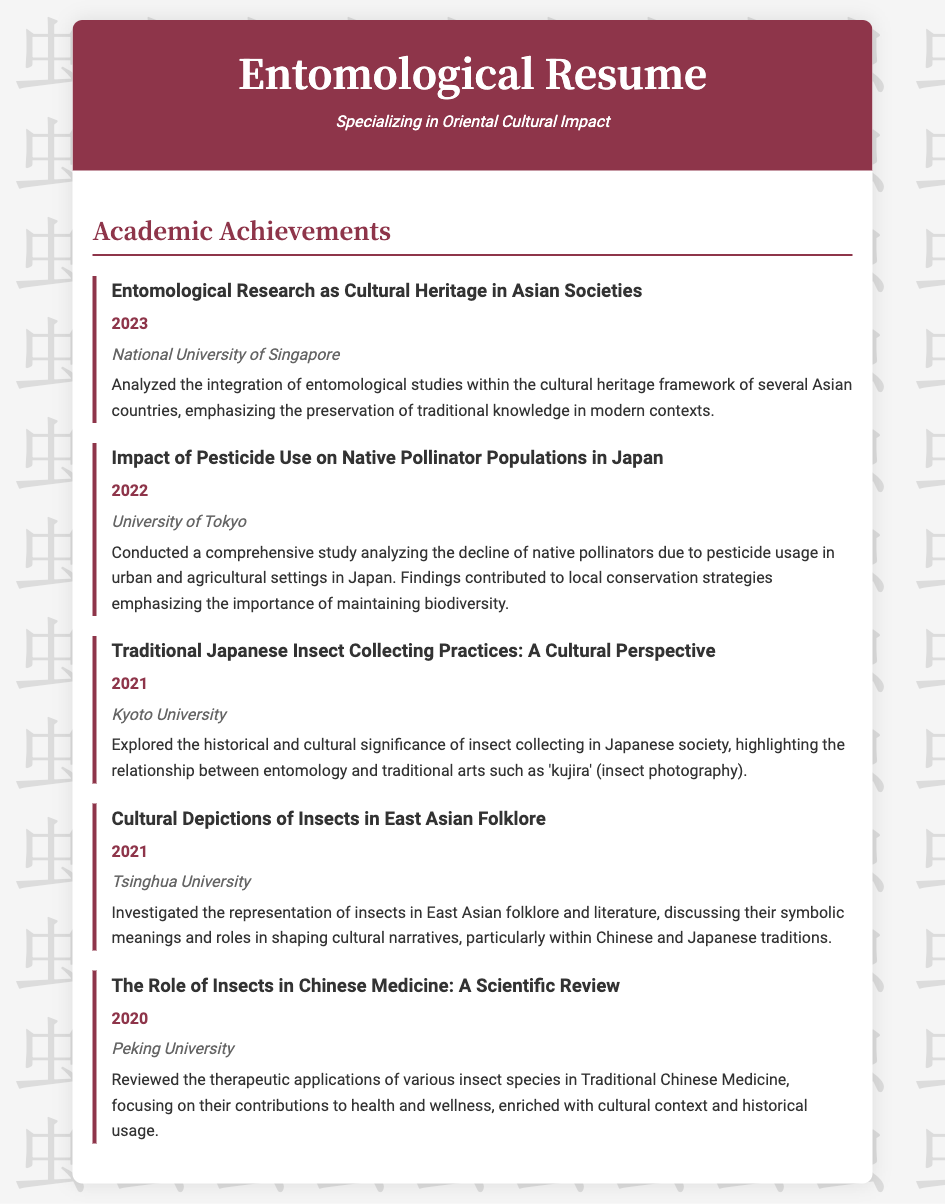What is the title of the most recent achievement? The title of the most recent achievement is listed at the top of the relevant section; it is "Entomological Research as Cultural Heritage in Asian Societies."
Answer: Entomological Research as Cultural Heritage in Asian Societies In which year was the achievement about pesticide use conducted? The year of the achievement about pesticide use can be found directly beneath its title, and it is "2022."
Answer: 2022 Which university was associated with the study of traditional Japanese insect collecting practices? The university associated with this study is mentioned in the context of the achievement; it is "Kyoto University."
Answer: Kyoto University What is the main focus of the achievement from Peking University? The document provides a summary of this achievement focusing on specific applications in a certain field; it is about "Traditional Chinese Medicine."
Answer: Traditional Chinese Medicine How many achievements listed are from the year 2021? The document lists achievements under years, and by counting the years 2021, it shows there are two listed.
Answer: 2 What cultural aspect do insects represent in the study from Tsinghua University? The achievement addresses cultural representations in folklore, indicating that the focus is on "symbolic meanings."
Answer: symbolic meanings Which institution conducted the analysis of native pollinator populations in Japan? The institution linked with the achievement regarding pollinator populations is stated within the context, which is "University of Tokyo."
Answer: University of Tokyo What is the underlying theme emphasized in the achievements listed? The achievements share a focus on cultural integration and preservation as emphasized throughout the sections; the underlying theme is "cultural impact."
Answer: cultural impact 